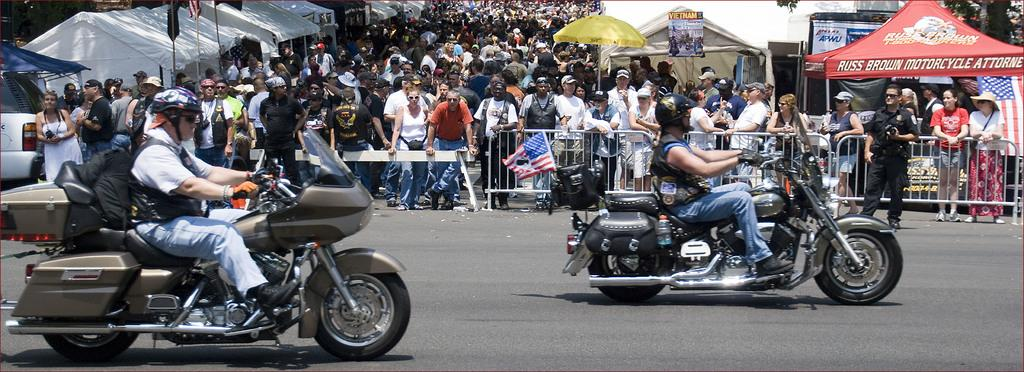What activity are the people engaged in on the road? People are riding bikes on the road. What are the people at the back holding? The people standing at the back are holding a metal grill. What type of temporary shelters can be seen in the image? There are tents on both the left and center of the image. What additional decorative or symbolic elements are present in the image? There are flags visible in the image. What type of riddle is written on the clock in the image? There is no clock present in the image, and therefore no riddle can be found on it. How many umbrellas are being used by the people in the image? There are no umbrellas visible in the image. 